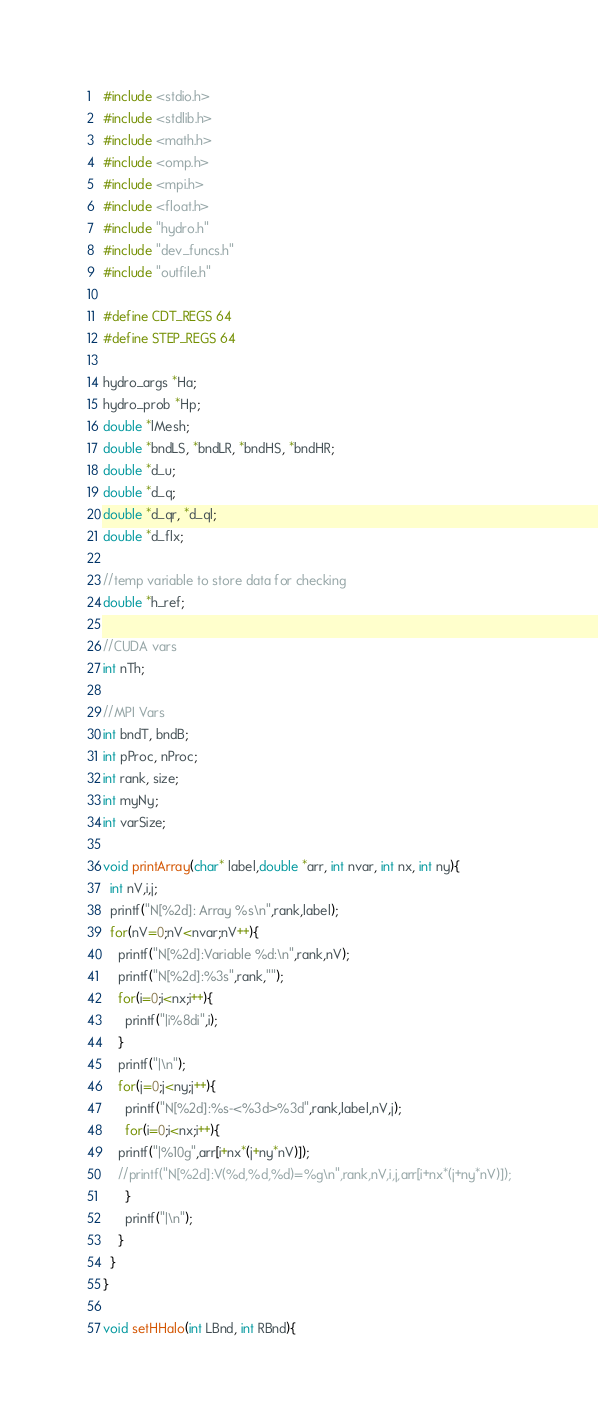<code> <loc_0><loc_0><loc_500><loc_500><_Cuda_>#include <stdio.h>
#include <stdlib.h>
#include <math.h>
#include <omp.h>
#include <mpi.h>
#include <float.h>
#include "hydro.h"
#include "dev_funcs.h"
#include "outfile.h"

#define CDT_REGS 64
#define STEP_REGS 64

hydro_args *Ha;
hydro_prob *Hp;
double *lMesh;
double *bndLS, *bndLR, *bndHS, *bndHR;
double *d_u;
double *d_q;
double *d_qr, *d_ql;
double *d_flx;

//temp variable to store data for checking
double *h_ref;

//CUDA vars
int nTh;

//MPI Vars
int bndT, bndB;
int pProc, nProc;
int rank, size;
int myNy;
int varSize;

void printArray(char* label,double *arr, int nvar, int nx, int ny){
  int nV,i,j;
  printf("N[%2d]: Array %s\n",rank,label);
  for(nV=0;nV<nvar;nV++){
    printf("N[%2d]:Variable %d:\n",rank,nV);
    printf("N[%2d]:%3s",rank,"");
    for(i=0;i<nx;i++){
      printf("|i%8di",i);
    }
    printf("|\n");
    for(j=0;j<ny;j++){
      printf("N[%2d]:%s-<%3d>%3d",rank,label,nV,j);
      for(i=0;i<nx;i++){
	printf("|%10g",arr[i+nx*(j+ny*nV)]);
	//printf("N[%2d]:V(%d,%d,%d)=%g\n",rank,nV,i,j,arr[i+nx*(j+ny*nV)]);
      }
      printf("|\n");
    }
  }
}

void setHHalo(int LBnd, int RBnd){</code> 